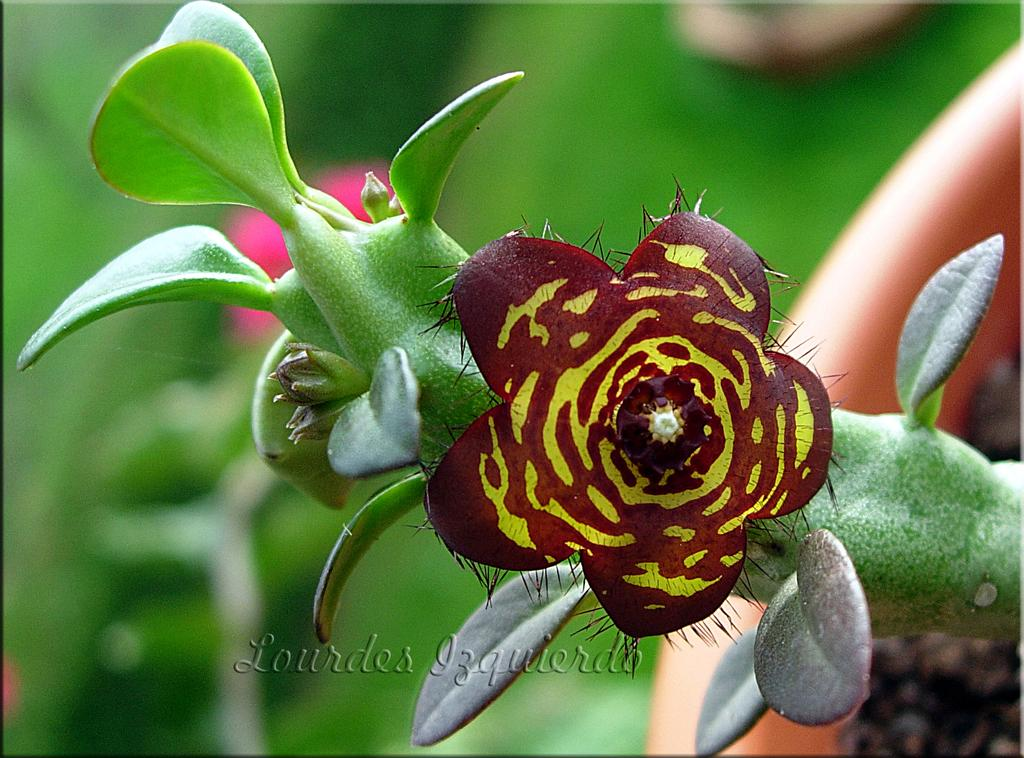What is the main subject of the image? There is a flower in the image. What parts of the flower are visible? Leaves and a stem are present in the image. Where are the flower, leaves, and stem located in the image? They are in the middle of the image. What can be seen at the bottom of the image? There is a watermark at the bottom of the image. What type of environment is visible in the background of the image? Greenery is visible in the background of the image. Can you tell me how many ladybugs are sitting on the flower in the image? There are no ladybugs present in the image; it only features a flower, leaves, and stem. What type of haircut does the flower have in the image? The flower does not have a haircut, as it is a plant and not a person. 